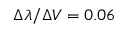Convert formula to latex. <formula><loc_0><loc_0><loc_500><loc_500>\Delta \lambda / \Delta V = 0 . 0 6</formula> 